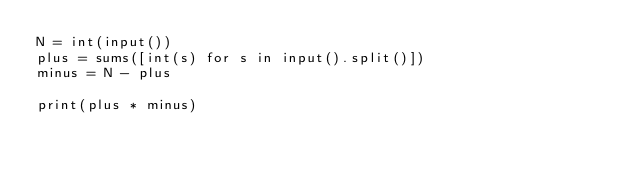Convert code to text. <code><loc_0><loc_0><loc_500><loc_500><_Python_>N = int(input())
plus = sums([int(s) for s in input().split()])
minus = N - plus

print(plus * minus)</code> 